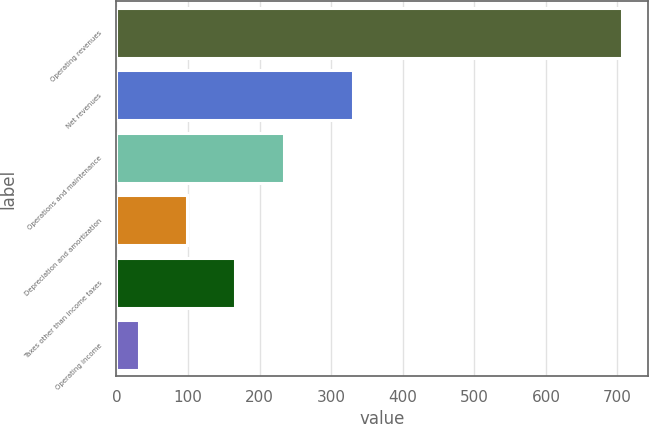Convert chart. <chart><loc_0><loc_0><loc_500><loc_500><bar_chart><fcel>Operating revenues<fcel>Net revenues<fcel>Operations and maintenance<fcel>Depreciation and amortization<fcel>Taxes other than income taxes<fcel>Operating income<nl><fcel>707<fcel>330<fcel>233.8<fcel>98.6<fcel>166.2<fcel>31<nl></chart> 